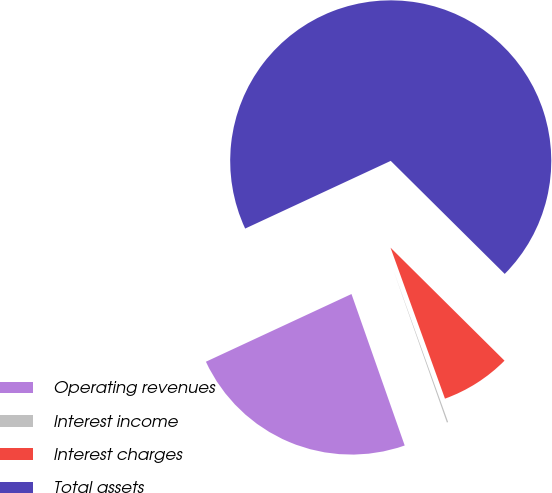Convert chart to OTSL. <chart><loc_0><loc_0><loc_500><loc_500><pie_chart><fcel>Operating revenues<fcel>Interest income<fcel>Interest charges<fcel>Total assets<nl><fcel>23.45%<fcel>0.13%<fcel>7.06%<fcel>69.36%<nl></chart> 